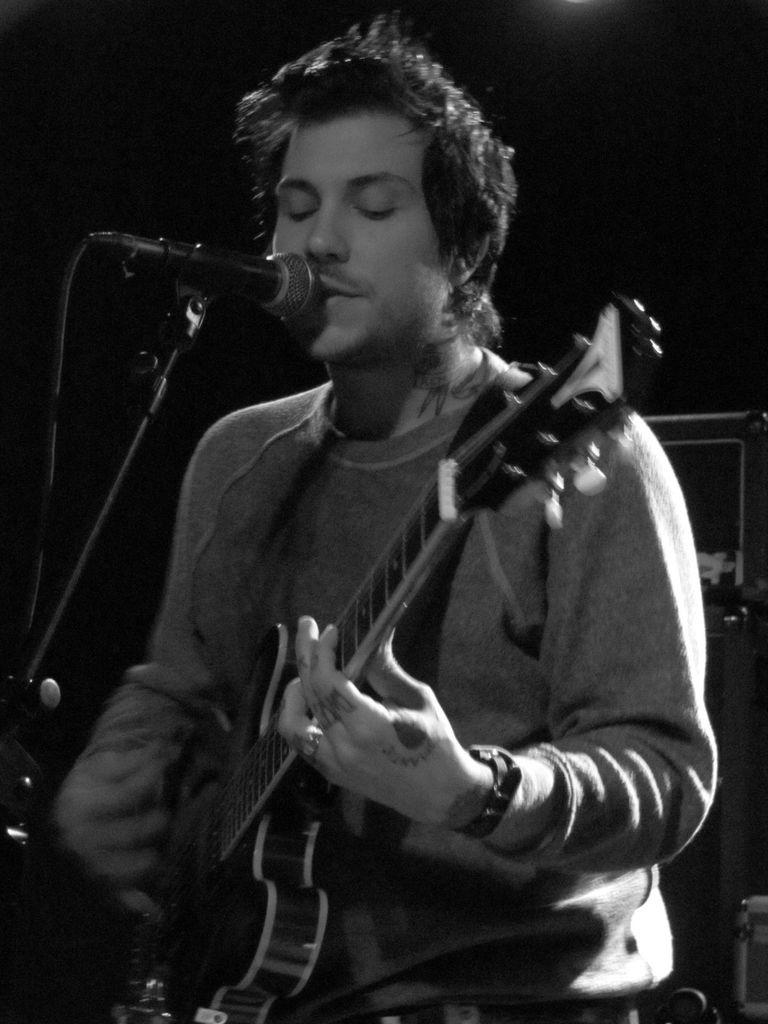Who is present in the image? There is a man in the image. What is the man doing in the image? The man is standing in the image. What object is the man holding in his hand? The man is holding a guitar in his hand. What equipment is set up in front of the man? There is a microphone with a stand in front of the man. What color scheme is used in the image? The image is in black and white color. What type of copper material is used to make the pen in the image? There is no pen present in the image, and therefore no copper material can be observed. 